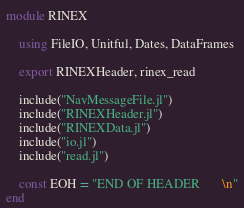<code> <loc_0><loc_0><loc_500><loc_500><_Julia_>module RINEX

    using FileIO, Unitful, Dates, DataFrames

    export RINEXHeader, rinex_read

    include("NavMessageFile.jl")
    include("RINEXHeader.jl")
    include("RINEXData.jl")
    include("io.jl")
    include("read.jl")
    
    const EOH = "END OF HEADER       \n"
end
</code> 